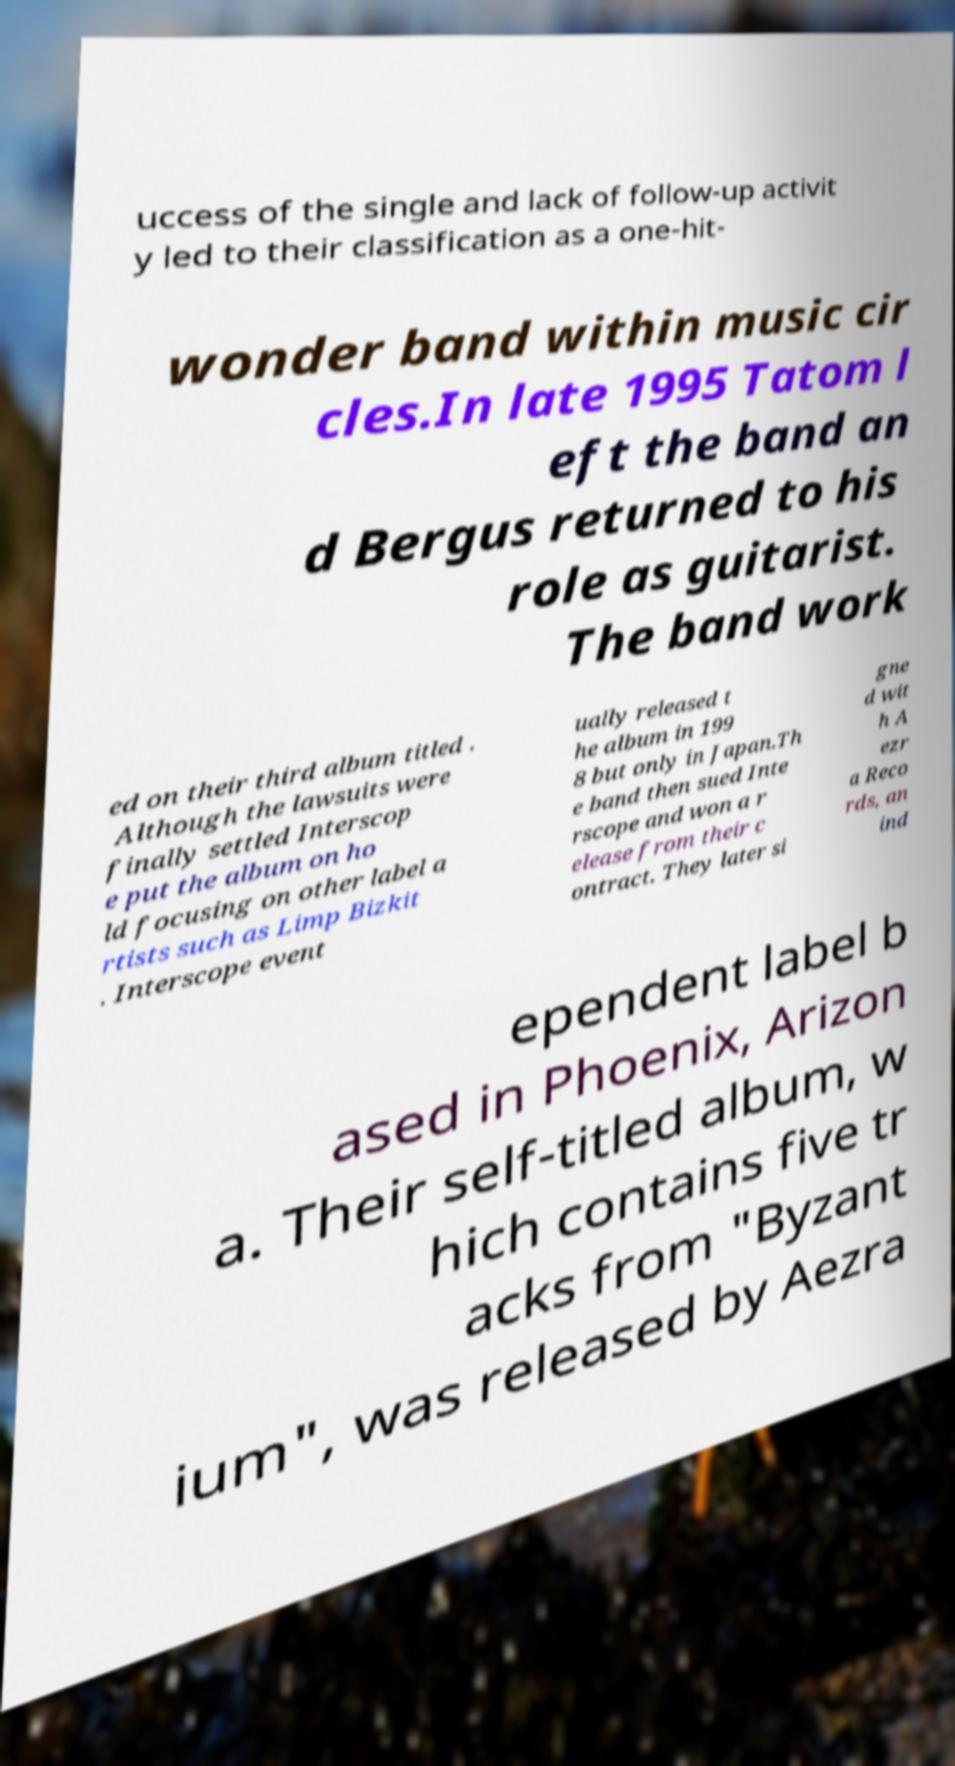For documentation purposes, I need the text within this image transcribed. Could you provide that? uccess of the single and lack of follow-up activit y led to their classification as a one-hit- wonder band within music cir cles.In late 1995 Tatom l eft the band an d Bergus returned to his role as guitarist. The band work ed on their third album titled . Although the lawsuits were finally settled Interscop e put the album on ho ld focusing on other label a rtists such as Limp Bizkit . Interscope event ually released t he album in 199 8 but only in Japan.Th e band then sued Inte rscope and won a r elease from their c ontract. They later si gne d wit h A ezr a Reco rds, an ind ependent label b ased in Phoenix, Arizon a. Their self-titled album, w hich contains five tr acks from "Byzant ium", was released by Aezra 